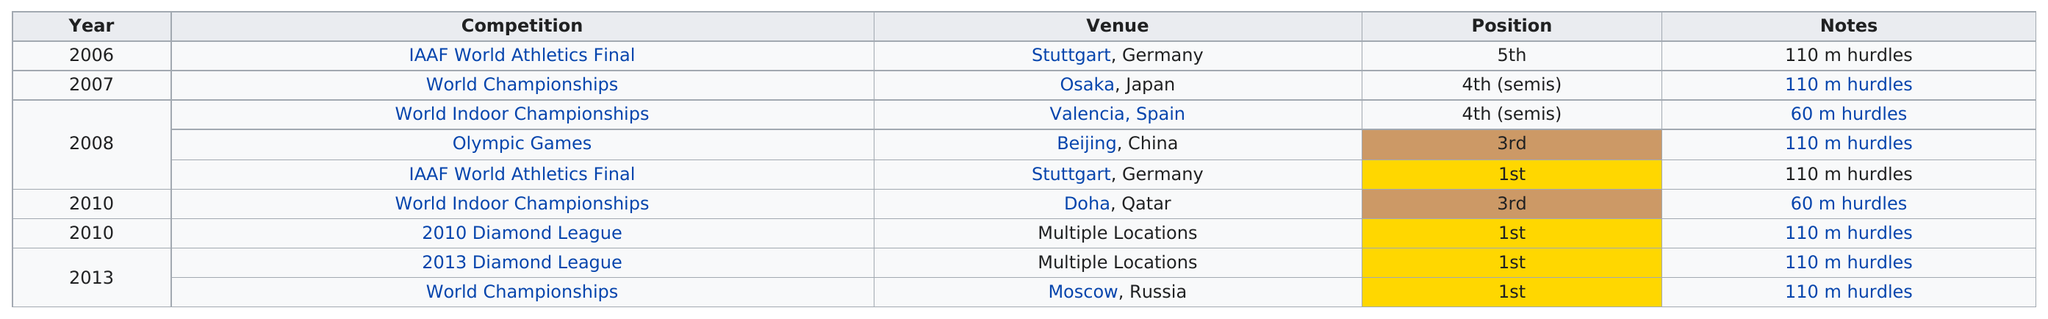Draw attention to some important aspects in this diagram. According to the chart provided, the first competition was held in Stuttgart, Germany. David Oliver won first place in three consecutive 100m hurdles competitions. David Oliver made his debut in 2006 by placing fifth in the IAAF World Athletics Final competition. The name of the most recent competition was the World Championships. The 110 m hurdles were recorded a total of 7 times in the notes. 